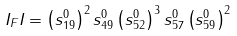Convert formula to latex. <formula><loc_0><loc_0><loc_500><loc_500>I _ { F } I = \left ( s ^ { 0 } _ { 1 9 } \right ) ^ { 2 } s ^ { 0 } _ { 4 9 } \left ( s ^ { 0 } _ { 5 2 } \right ) ^ { 3 } s ^ { 0 } _ { 5 7 } \left ( s ^ { 0 } _ { 5 9 } \right ) ^ { 2 }</formula> 